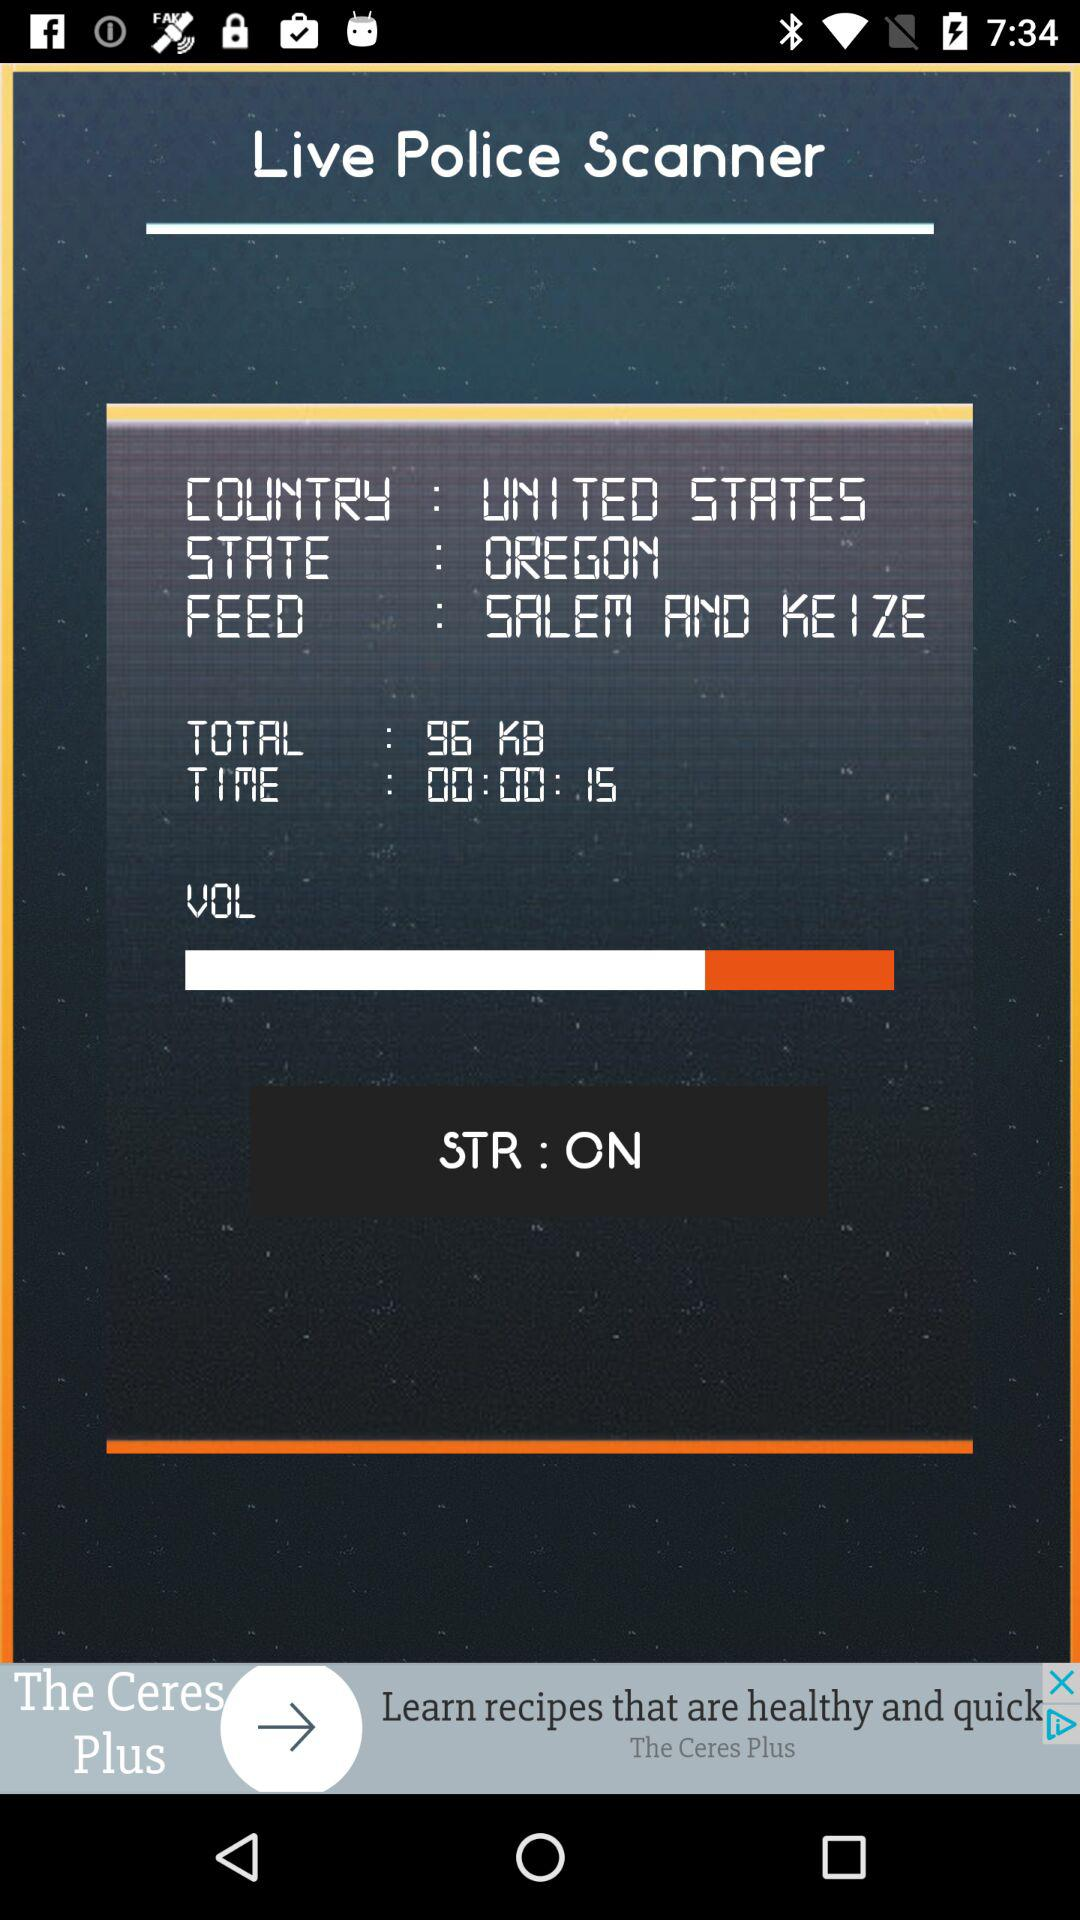How many total KB are shown? The total shown KB is 96. 